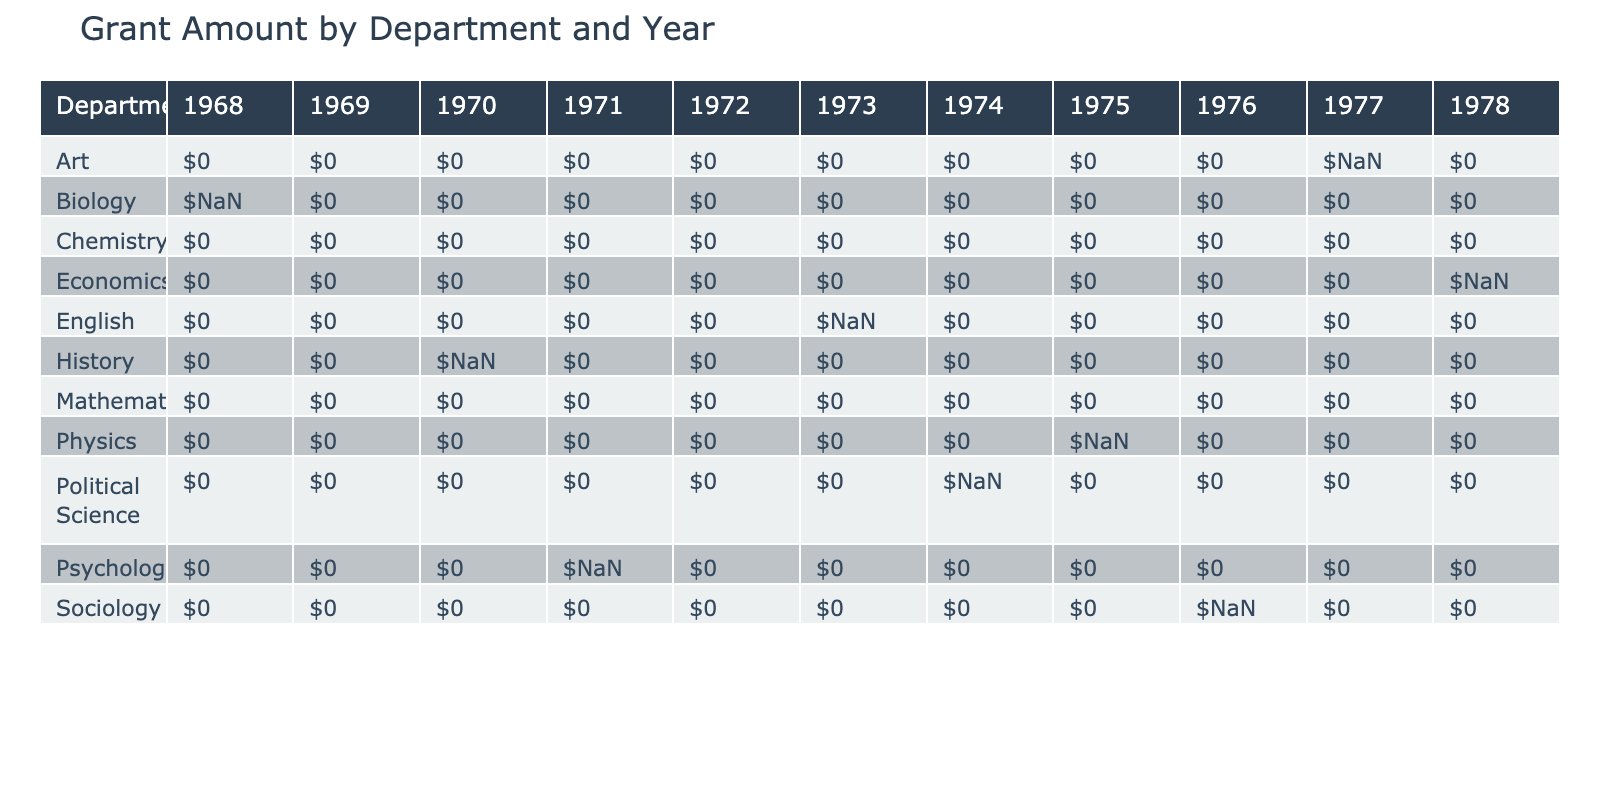What was the total grant amount received by the Biology department in 1968? Referring to the table, we can see that the Biology department received a grant amount of $15,000 in 1968.
Answer: $15,000 Which department received the highest grant amount in 1975? In 1975, the Physics department received a grant amount of $20,000, which is the highest amount listed for that year.
Answer: $20,000 Did any faculty member in the Mathematics department secure a grant during this period? The table shows that Dr. Alan Foster from the Mathematics department had a grant amount of $0, indicating that no grant was secured during this time.
Answer: No What is the total grant amount received by the Sociology department from all years? For the Sociology department, there is only one entry with a grant amount of $10,000 in 1976, therefore the total is $10,000.
Answer: $10,000 Which faculty member received a grant from the US Department of Education? The table lists Dr. Linda Thompson from the Psychology department as the faculty member who received a grant amount of $8,000 from the US Department of Education in 1971.
Answer: Dr. Linda Thompson What was the average grant amount received by the English department between 1973 and 1978? The total grant amount for the English department is $3,000 from 1973, with no entries for the following years. Therefore, the average grant amount is $3,000 divided by 1, which remains $3,000.
Answer: $3,000 In which year did the Art department receive its grant, and what was the amount? The table indicates that the Art department received a grant of $5,000 in 1977 as indicated in the data provided.
Answer: 1977, $5,000 What was the total grant amount received in 1974 by all departments combined? The table shows grant amounts for 1974: Political Science received $6,000. The total for all departments in 1974 is thus $6,000.
Answer: $6,000 Did Dr. Margaret Carey publish a journal article in 1968? Yes, according to the table, Dr. Margaret Carey published a journal article titled "Ecology of Susquehanna Valley Flora" in 1968.
Answer: Yes 